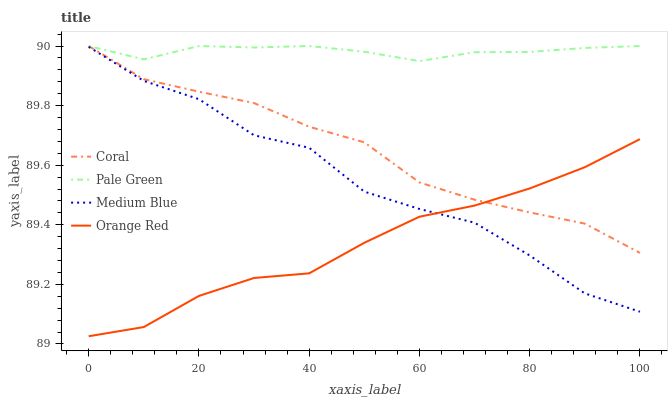Does Orange Red have the minimum area under the curve?
Answer yes or no. Yes. Does Pale Green have the maximum area under the curve?
Answer yes or no. Yes. Does Medium Blue have the minimum area under the curve?
Answer yes or no. No. Does Medium Blue have the maximum area under the curve?
Answer yes or no. No. Is Pale Green the smoothest?
Answer yes or no. Yes. Is Medium Blue the roughest?
Answer yes or no. Yes. Is Medium Blue the smoothest?
Answer yes or no. No. Is Pale Green the roughest?
Answer yes or no. No. Does Orange Red have the lowest value?
Answer yes or no. Yes. Does Medium Blue have the lowest value?
Answer yes or no. No. Does Pale Green have the highest value?
Answer yes or no. Yes. Does Medium Blue have the highest value?
Answer yes or no. No. Is Medium Blue less than Pale Green?
Answer yes or no. Yes. Is Pale Green greater than Orange Red?
Answer yes or no. Yes. Does Medium Blue intersect Orange Red?
Answer yes or no. Yes. Is Medium Blue less than Orange Red?
Answer yes or no. No. Is Medium Blue greater than Orange Red?
Answer yes or no. No. Does Medium Blue intersect Pale Green?
Answer yes or no. No. 